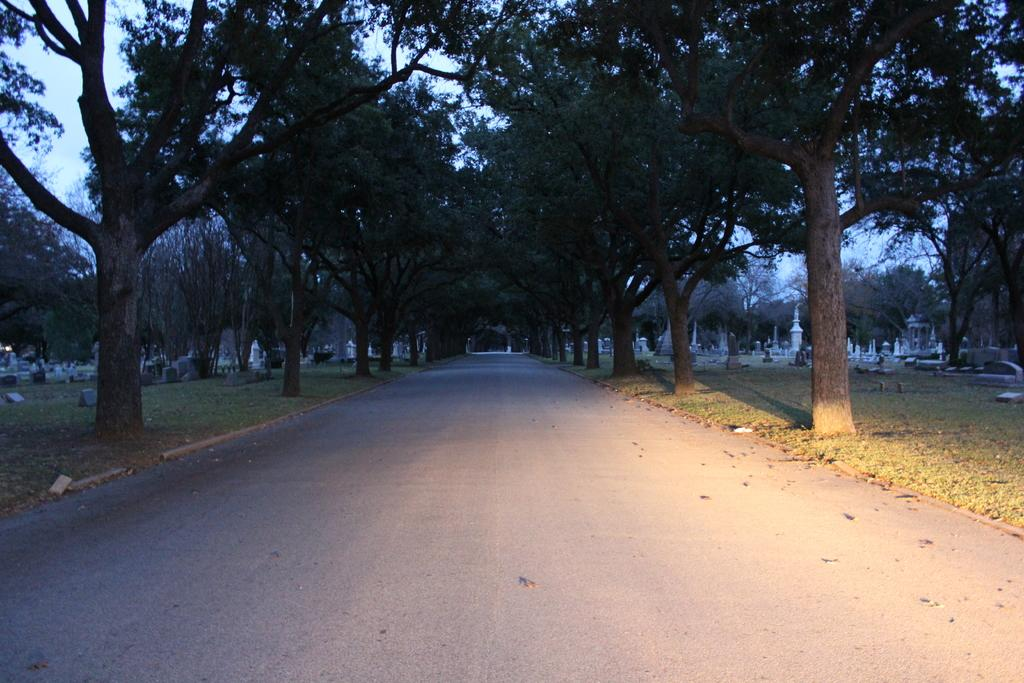What is located in the foreground of the image? There is a road in the foreground of the image. What can be seen on either side of the road? Trees are present on either side of the road. What is visible in the background of the image? There are headstones and the sky in the background of the image. What type of curtain can be seen hanging from the headstones in the image? There are no curtains present in the image; the headstones are not associated with any curtains. 